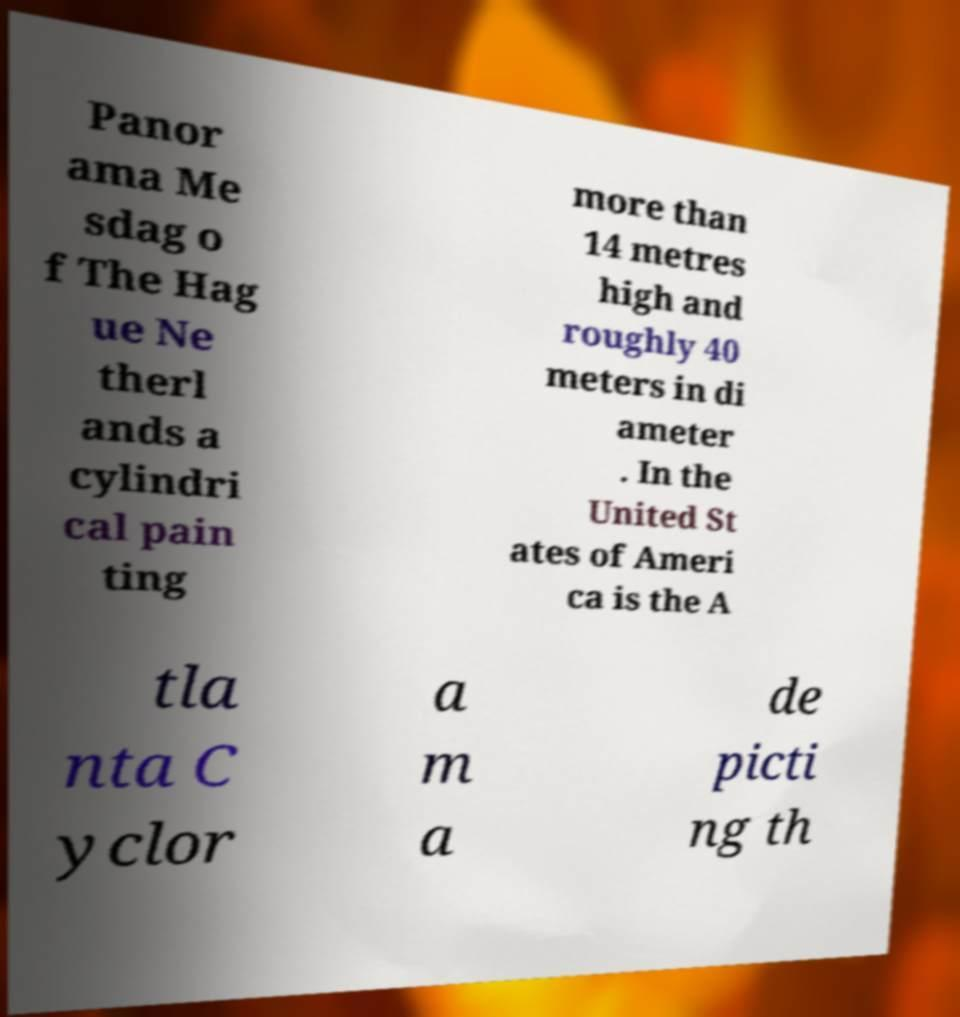I need the written content from this picture converted into text. Can you do that? Panor ama Me sdag o f The Hag ue Ne therl ands a cylindri cal pain ting more than 14 metres high and roughly 40 meters in di ameter . In the United St ates of Ameri ca is the A tla nta C yclor a m a de picti ng th 